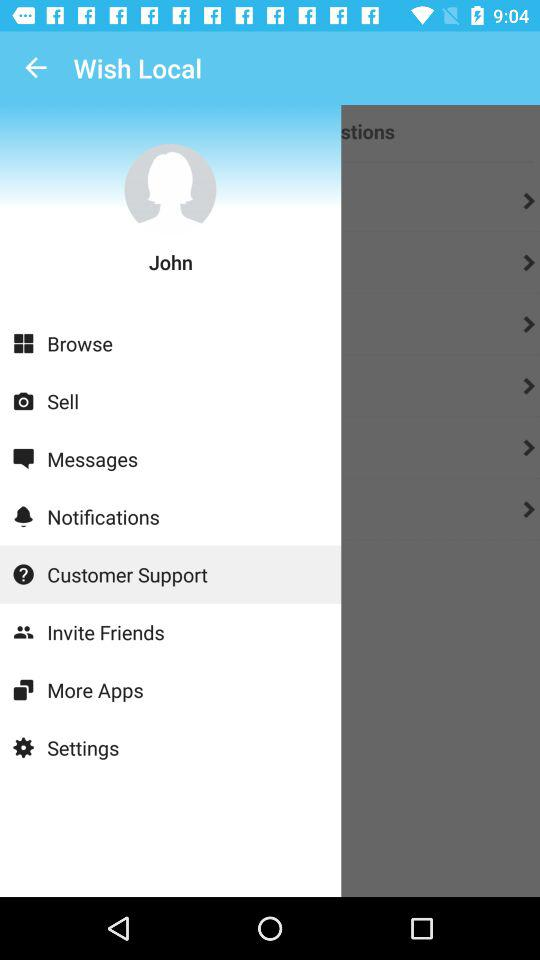What is the application name? The application name is "Wish Local". 